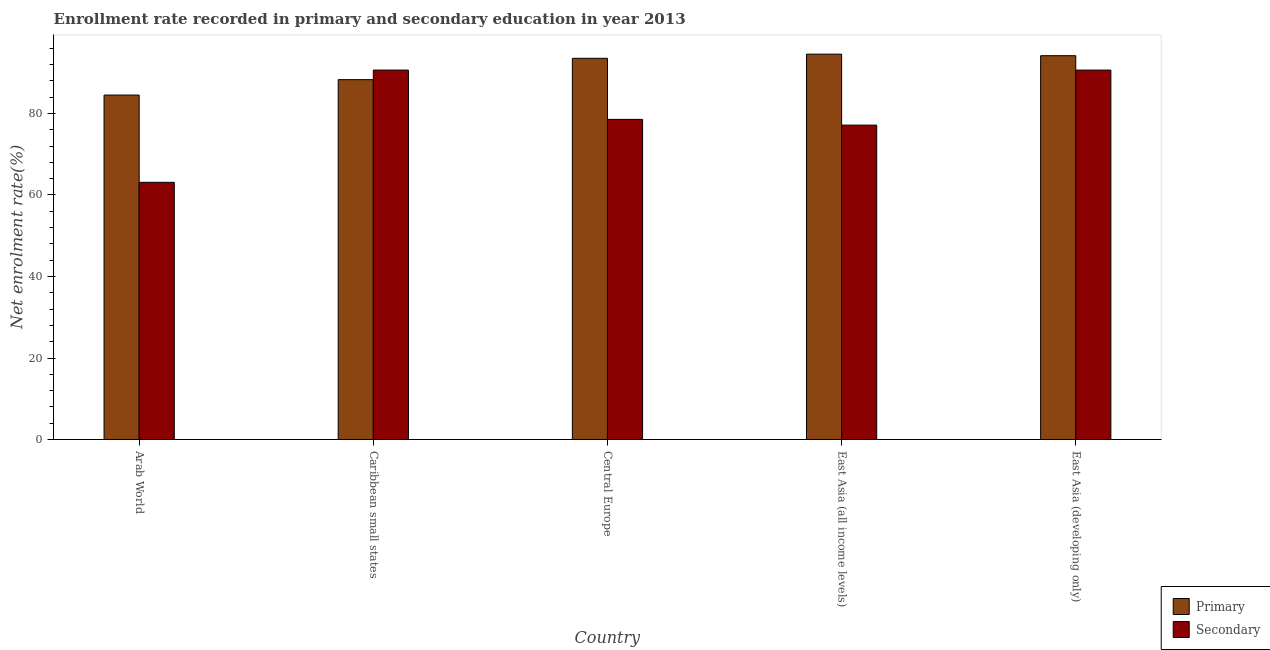How many different coloured bars are there?
Make the answer very short. 2. How many groups of bars are there?
Offer a terse response. 5. Are the number of bars on each tick of the X-axis equal?
Offer a very short reply. Yes. What is the label of the 5th group of bars from the left?
Offer a very short reply. East Asia (developing only). In how many cases, is the number of bars for a given country not equal to the number of legend labels?
Offer a very short reply. 0. What is the enrollment rate in secondary education in Arab World?
Keep it short and to the point. 63.1. Across all countries, what is the maximum enrollment rate in primary education?
Ensure brevity in your answer.  94.55. Across all countries, what is the minimum enrollment rate in primary education?
Make the answer very short. 84.51. In which country was the enrollment rate in primary education maximum?
Provide a succinct answer. East Asia (all income levels). In which country was the enrollment rate in secondary education minimum?
Ensure brevity in your answer.  Arab World. What is the total enrollment rate in secondary education in the graph?
Your answer should be very brief. 400.06. What is the difference between the enrollment rate in secondary education in East Asia (all income levels) and that in East Asia (developing only)?
Your response must be concise. -13.5. What is the difference between the enrollment rate in primary education in East Asia (developing only) and the enrollment rate in secondary education in East Asia (all income levels)?
Provide a succinct answer. 17.03. What is the average enrollment rate in primary education per country?
Make the answer very short. 91.01. What is the difference between the enrollment rate in primary education and enrollment rate in secondary education in Arab World?
Your answer should be very brief. 21.41. What is the ratio of the enrollment rate in secondary education in Arab World to that in Caribbean small states?
Your answer should be very brief. 0.7. Is the enrollment rate in secondary education in Arab World less than that in Caribbean small states?
Keep it short and to the point. Yes. Is the difference between the enrollment rate in primary education in Caribbean small states and Central Europe greater than the difference between the enrollment rate in secondary education in Caribbean small states and Central Europe?
Ensure brevity in your answer.  No. What is the difference between the highest and the second highest enrollment rate in primary education?
Provide a short and direct response. 0.38. What is the difference between the highest and the lowest enrollment rate in secondary education?
Your answer should be compact. 27.54. What does the 1st bar from the left in East Asia (developing only) represents?
Give a very brief answer. Primary. What does the 2nd bar from the right in East Asia (all income levels) represents?
Offer a terse response. Primary. Are all the bars in the graph horizontal?
Your response must be concise. No. Where does the legend appear in the graph?
Your answer should be very brief. Bottom right. How are the legend labels stacked?
Make the answer very short. Vertical. What is the title of the graph?
Offer a very short reply. Enrollment rate recorded in primary and secondary education in year 2013. Does "Taxes on exports" appear as one of the legend labels in the graph?
Provide a succinct answer. No. What is the label or title of the Y-axis?
Your response must be concise. Net enrolment rate(%). What is the Net enrolment rate(%) in Primary in Arab World?
Give a very brief answer. 84.51. What is the Net enrolment rate(%) of Secondary in Arab World?
Your answer should be compact. 63.1. What is the Net enrolment rate(%) in Primary in Caribbean small states?
Offer a very short reply. 88.29. What is the Net enrolment rate(%) in Secondary in Caribbean small states?
Your response must be concise. 90.64. What is the Net enrolment rate(%) of Primary in Central Europe?
Make the answer very short. 93.53. What is the Net enrolment rate(%) in Secondary in Central Europe?
Ensure brevity in your answer.  78.54. What is the Net enrolment rate(%) in Primary in East Asia (all income levels)?
Your answer should be compact. 94.55. What is the Net enrolment rate(%) in Secondary in East Asia (all income levels)?
Offer a very short reply. 77.14. What is the Net enrolment rate(%) of Primary in East Asia (developing only)?
Your response must be concise. 94.17. What is the Net enrolment rate(%) in Secondary in East Asia (developing only)?
Make the answer very short. 90.64. Across all countries, what is the maximum Net enrolment rate(%) in Primary?
Make the answer very short. 94.55. Across all countries, what is the maximum Net enrolment rate(%) of Secondary?
Your answer should be compact. 90.64. Across all countries, what is the minimum Net enrolment rate(%) in Primary?
Your answer should be compact. 84.51. Across all countries, what is the minimum Net enrolment rate(%) of Secondary?
Ensure brevity in your answer.  63.1. What is the total Net enrolment rate(%) in Primary in the graph?
Your answer should be very brief. 455.06. What is the total Net enrolment rate(%) in Secondary in the graph?
Your answer should be very brief. 400.06. What is the difference between the Net enrolment rate(%) in Primary in Arab World and that in Caribbean small states?
Provide a short and direct response. -3.78. What is the difference between the Net enrolment rate(%) of Secondary in Arab World and that in Caribbean small states?
Offer a terse response. -27.54. What is the difference between the Net enrolment rate(%) in Primary in Arab World and that in Central Europe?
Provide a succinct answer. -9.02. What is the difference between the Net enrolment rate(%) of Secondary in Arab World and that in Central Europe?
Provide a short and direct response. -15.44. What is the difference between the Net enrolment rate(%) of Primary in Arab World and that in East Asia (all income levels)?
Your response must be concise. -10.04. What is the difference between the Net enrolment rate(%) of Secondary in Arab World and that in East Asia (all income levels)?
Your answer should be compact. -14.04. What is the difference between the Net enrolment rate(%) in Primary in Arab World and that in East Asia (developing only)?
Give a very brief answer. -9.66. What is the difference between the Net enrolment rate(%) in Secondary in Arab World and that in East Asia (developing only)?
Make the answer very short. -27.54. What is the difference between the Net enrolment rate(%) in Primary in Caribbean small states and that in Central Europe?
Provide a succinct answer. -5.24. What is the difference between the Net enrolment rate(%) in Secondary in Caribbean small states and that in Central Europe?
Your answer should be very brief. 12.1. What is the difference between the Net enrolment rate(%) of Primary in Caribbean small states and that in East Asia (all income levels)?
Give a very brief answer. -6.26. What is the difference between the Net enrolment rate(%) of Secondary in Caribbean small states and that in East Asia (all income levels)?
Ensure brevity in your answer.  13.51. What is the difference between the Net enrolment rate(%) of Primary in Caribbean small states and that in East Asia (developing only)?
Ensure brevity in your answer.  -5.88. What is the difference between the Net enrolment rate(%) in Secondary in Caribbean small states and that in East Asia (developing only)?
Provide a succinct answer. 0. What is the difference between the Net enrolment rate(%) of Primary in Central Europe and that in East Asia (all income levels)?
Your answer should be very brief. -1.02. What is the difference between the Net enrolment rate(%) of Secondary in Central Europe and that in East Asia (all income levels)?
Offer a very short reply. 1.41. What is the difference between the Net enrolment rate(%) in Primary in Central Europe and that in East Asia (developing only)?
Keep it short and to the point. -0.64. What is the difference between the Net enrolment rate(%) in Secondary in Central Europe and that in East Asia (developing only)?
Offer a terse response. -12.1. What is the difference between the Net enrolment rate(%) of Primary in East Asia (all income levels) and that in East Asia (developing only)?
Your answer should be compact. 0.38. What is the difference between the Net enrolment rate(%) in Secondary in East Asia (all income levels) and that in East Asia (developing only)?
Your answer should be compact. -13.5. What is the difference between the Net enrolment rate(%) in Primary in Arab World and the Net enrolment rate(%) in Secondary in Caribbean small states?
Keep it short and to the point. -6.13. What is the difference between the Net enrolment rate(%) of Primary in Arab World and the Net enrolment rate(%) of Secondary in Central Europe?
Make the answer very short. 5.97. What is the difference between the Net enrolment rate(%) of Primary in Arab World and the Net enrolment rate(%) of Secondary in East Asia (all income levels)?
Provide a short and direct response. 7.38. What is the difference between the Net enrolment rate(%) in Primary in Arab World and the Net enrolment rate(%) in Secondary in East Asia (developing only)?
Your answer should be very brief. -6.13. What is the difference between the Net enrolment rate(%) in Primary in Caribbean small states and the Net enrolment rate(%) in Secondary in Central Europe?
Provide a short and direct response. 9.75. What is the difference between the Net enrolment rate(%) in Primary in Caribbean small states and the Net enrolment rate(%) in Secondary in East Asia (all income levels)?
Keep it short and to the point. 11.16. What is the difference between the Net enrolment rate(%) of Primary in Caribbean small states and the Net enrolment rate(%) of Secondary in East Asia (developing only)?
Your answer should be very brief. -2.35. What is the difference between the Net enrolment rate(%) in Primary in Central Europe and the Net enrolment rate(%) in Secondary in East Asia (all income levels)?
Your answer should be compact. 16.39. What is the difference between the Net enrolment rate(%) in Primary in Central Europe and the Net enrolment rate(%) in Secondary in East Asia (developing only)?
Your answer should be very brief. 2.89. What is the difference between the Net enrolment rate(%) of Primary in East Asia (all income levels) and the Net enrolment rate(%) of Secondary in East Asia (developing only)?
Your answer should be compact. 3.91. What is the average Net enrolment rate(%) in Primary per country?
Your answer should be compact. 91.01. What is the average Net enrolment rate(%) of Secondary per country?
Provide a short and direct response. 80.01. What is the difference between the Net enrolment rate(%) of Primary and Net enrolment rate(%) of Secondary in Arab World?
Keep it short and to the point. 21.41. What is the difference between the Net enrolment rate(%) of Primary and Net enrolment rate(%) of Secondary in Caribbean small states?
Your response must be concise. -2.35. What is the difference between the Net enrolment rate(%) of Primary and Net enrolment rate(%) of Secondary in Central Europe?
Ensure brevity in your answer.  14.99. What is the difference between the Net enrolment rate(%) in Primary and Net enrolment rate(%) in Secondary in East Asia (all income levels)?
Keep it short and to the point. 17.41. What is the difference between the Net enrolment rate(%) in Primary and Net enrolment rate(%) in Secondary in East Asia (developing only)?
Your answer should be very brief. 3.53. What is the ratio of the Net enrolment rate(%) in Primary in Arab World to that in Caribbean small states?
Offer a very short reply. 0.96. What is the ratio of the Net enrolment rate(%) of Secondary in Arab World to that in Caribbean small states?
Your answer should be compact. 0.7. What is the ratio of the Net enrolment rate(%) in Primary in Arab World to that in Central Europe?
Give a very brief answer. 0.9. What is the ratio of the Net enrolment rate(%) in Secondary in Arab World to that in Central Europe?
Your answer should be very brief. 0.8. What is the ratio of the Net enrolment rate(%) of Primary in Arab World to that in East Asia (all income levels)?
Ensure brevity in your answer.  0.89. What is the ratio of the Net enrolment rate(%) of Secondary in Arab World to that in East Asia (all income levels)?
Offer a terse response. 0.82. What is the ratio of the Net enrolment rate(%) in Primary in Arab World to that in East Asia (developing only)?
Give a very brief answer. 0.9. What is the ratio of the Net enrolment rate(%) in Secondary in Arab World to that in East Asia (developing only)?
Keep it short and to the point. 0.7. What is the ratio of the Net enrolment rate(%) of Primary in Caribbean small states to that in Central Europe?
Provide a succinct answer. 0.94. What is the ratio of the Net enrolment rate(%) of Secondary in Caribbean small states to that in Central Europe?
Give a very brief answer. 1.15. What is the ratio of the Net enrolment rate(%) in Primary in Caribbean small states to that in East Asia (all income levels)?
Offer a very short reply. 0.93. What is the ratio of the Net enrolment rate(%) of Secondary in Caribbean small states to that in East Asia (all income levels)?
Your answer should be very brief. 1.18. What is the ratio of the Net enrolment rate(%) in Primary in Caribbean small states to that in East Asia (developing only)?
Provide a short and direct response. 0.94. What is the ratio of the Net enrolment rate(%) of Secondary in Caribbean small states to that in East Asia (developing only)?
Provide a short and direct response. 1. What is the ratio of the Net enrolment rate(%) of Secondary in Central Europe to that in East Asia (all income levels)?
Your answer should be very brief. 1.02. What is the ratio of the Net enrolment rate(%) in Secondary in Central Europe to that in East Asia (developing only)?
Offer a very short reply. 0.87. What is the ratio of the Net enrolment rate(%) of Primary in East Asia (all income levels) to that in East Asia (developing only)?
Your answer should be very brief. 1. What is the ratio of the Net enrolment rate(%) of Secondary in East Asia (all income levels) to that in East Asia (developing only)?
Give a very brief answer. 0.85. What is the difference between the highest and the second highest Net enrolment rate(%) in Primary?
Your answer should be very brief. 0.38. What is the difference between the highest and the second highest Net enrolment rate(%) of Secondary?
Ensure brevity in your answer.  0. What is the difference between the highest and the lowest Net enrolment rate(%) of Primary?
Give a very brief answer. 10.04. What is the difference between the highest and the lowest Net enrolment rate(%) of Secondary?
Your answer should be compact. 27.54. 